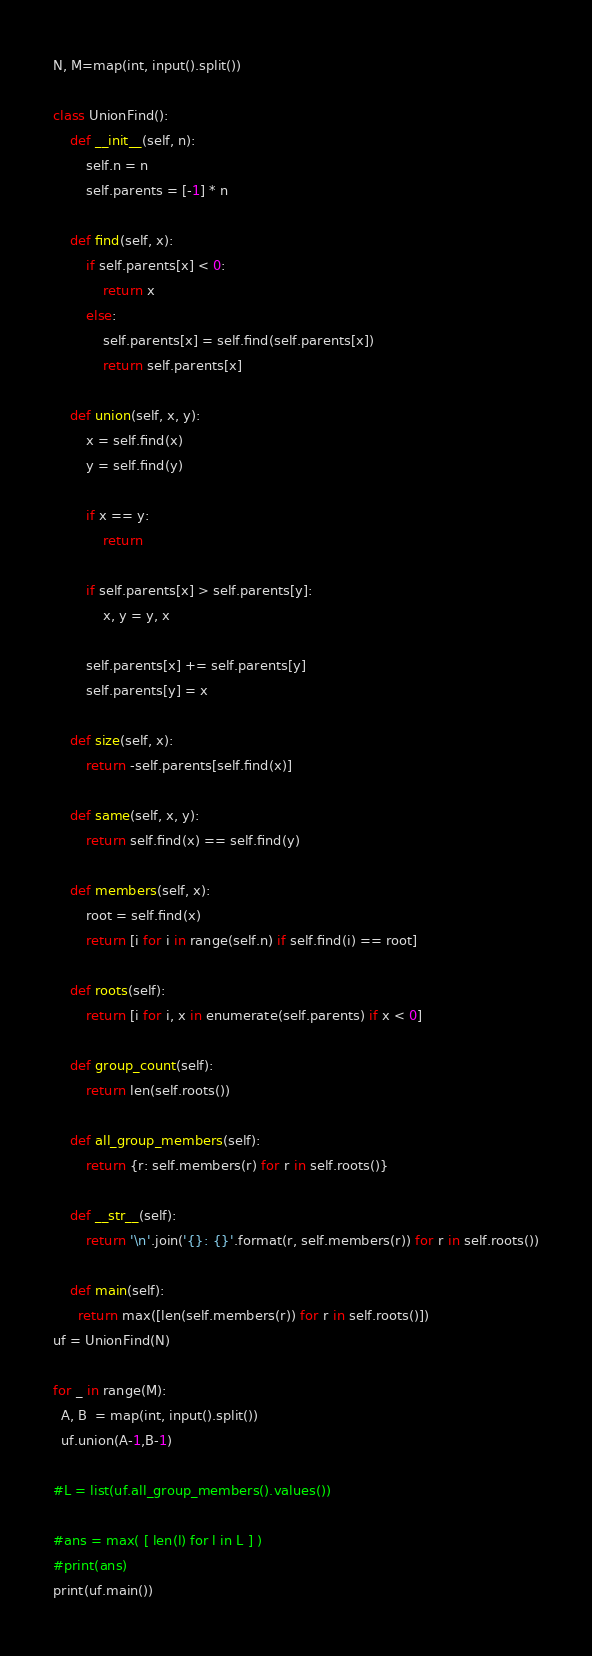<code> <loc_0><loc_0><loc_500><loc_500><_Python_>N, M=map(int, input().split())

class UnionFind():
    def __init__(self, n):
        self.n = n
        self.parents = [-1] * n

    def find(self, x):
        if self.parents[x] < 0:
            return x
        else:
            self.parents[x] = self.find(self.parents[x])
            return self.parents[x]

    def union(self, x, y):
        x = self.find(x)
        y = self.find(y)

        if x == y:
            return

        if self.parents[x] > self.parents[y]:
            x, y = y, x

        self.parents[x] += self.parents[y]
        self.parents[y] = x

    def size(self, x):
        return -self.parents[self.find(x)]

    def same(self, x, y):
        return self.find(x) == self.find(y)

    def members(self, x):
        root = self.find(x)
        return [i for i in range(self.n) if self.find(i) == root]

    def roots(self):
        return [i for i, x in enumerate(self.parents) if x < 0]

    def group_count(self):
        return len(self.roots())

    def all_group_members(self):
        return {r: self.members(r) for r in self.roots()}

    def __str__(self):
        return '\n'.join('{}: {}'.format(r, self.members(r)) for r in self.roots())
      
    def main(self):
      return max([len(self.members(r)) for r in self.roots()])
uf = UnionFind(N)

for _ in range(M):
  A, B  = map(int, input().split())
  uf.union(A-1,B-1)
  
#L = list(uf.all_group_members().values())

#ans = max( [ len(l) for l in L ] )
#print(ans)
print(uf.main())</code> 